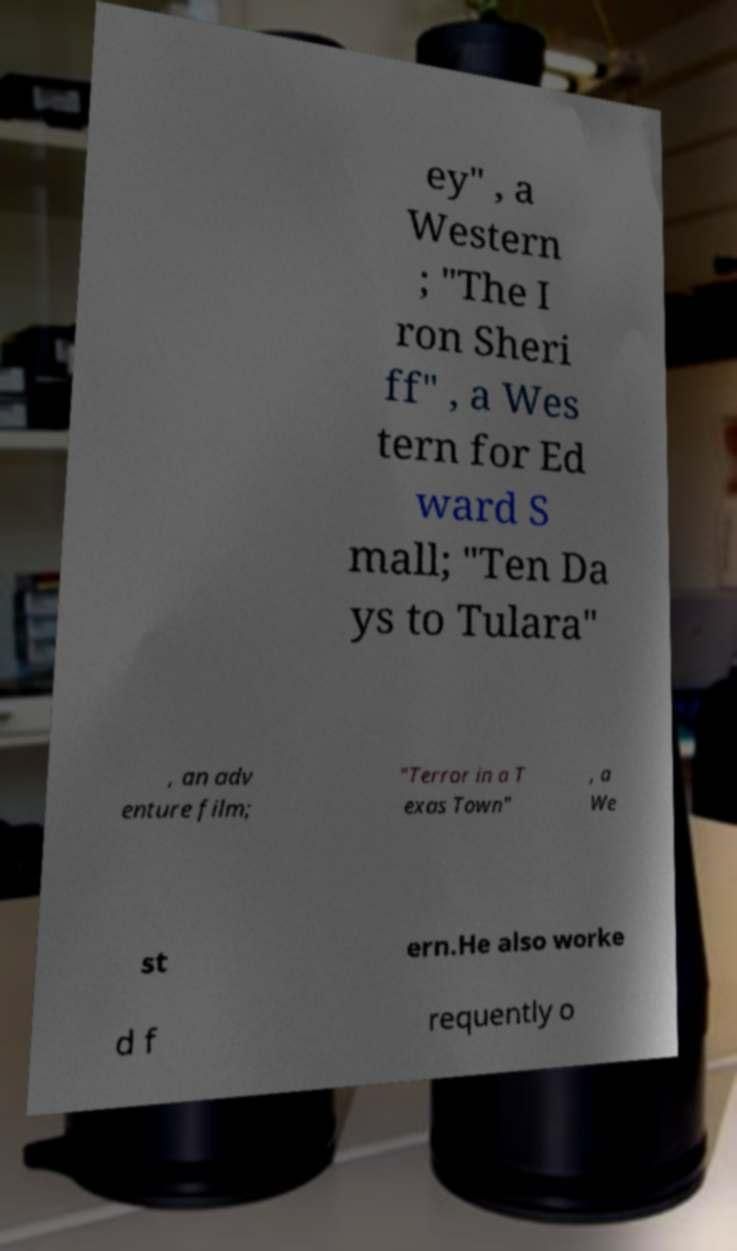For documentation purposes, I need the text within this image transcribed. Could you provide that? ey" , a Western ; "The I ron Sheri ff" , a Wes tern for Ed ward S mall; "Ten Da ys to Tulara" , an adv enture film; "Terror in a T exas Town" , a We st ern.He also worke d f requently o 